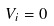<formula> <loc_0><loc_0><loc_500><loc_500>V _ { i } = 0</formula> 